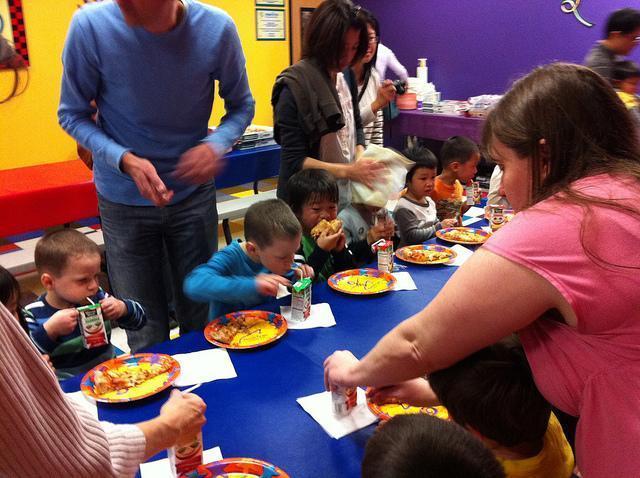How many dining tables are there?
Give a very brief answer. 3. How many people are in the photo?
Give a very brief answer. 14. 